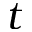Convert formula to latex. <formula><loc_0><loc_0><loc_500><loc_500>t</formula> 